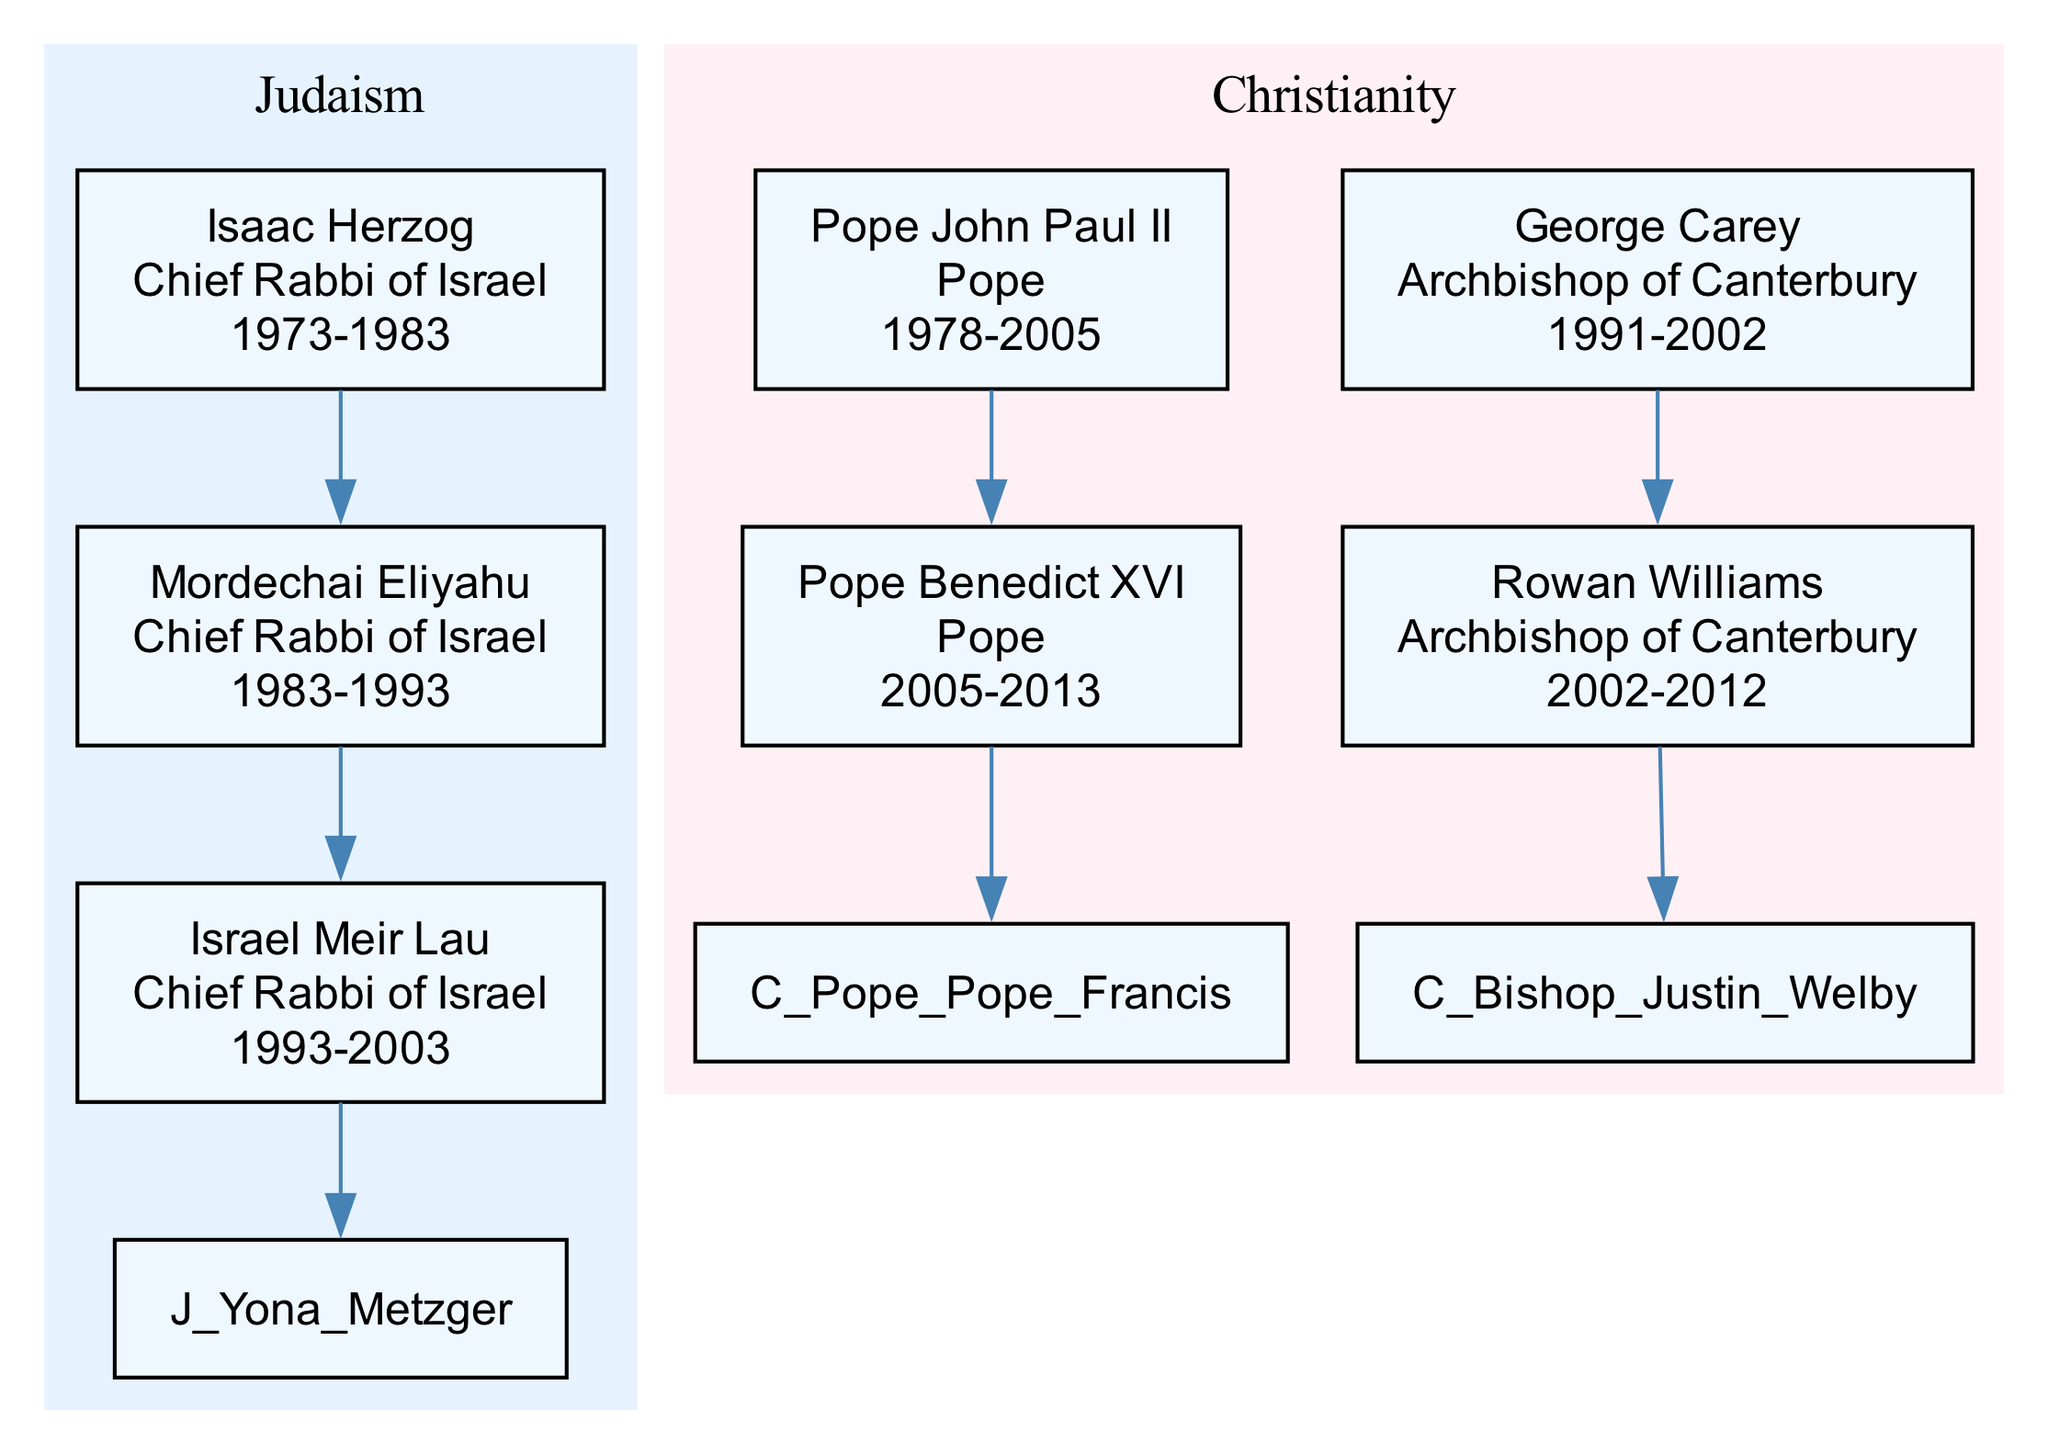What is the title of Isaac Herzog? The diagram shows that Isaac Herzog held the title of "Chief Rabbi of Israel." This information is directly presented in the node associated with his name in the Judaism section.
Answer: Chief Rabbi of Israel Who succeeded Pope Benedict XVI? The diagram indicates that Pope Benedict XVI's successor is Pope Francis. This is shown by the edge that connects their respective nodes in the Christianity section.
Answer: Pope Francis How many chief rabbis are mentioned in the diagram? The diagram lists three chief rabbis of Israel: Isaac Herzog, Mordechai Eliyahu, and Israel Meir Lau. Counting the entries under the Judaism lineage, we arrive at the total.
Answer: 3 What years did Rowan Williams serve as Archbishop of Canterbury? The diagram specifies that Rowan Williams was active as Archbishop of Canterbury from 2002 to 2012. This information is clearly shown in his node within the Christianity section.
Answer: 2002-2012 Which religious leader had the longest tenure in the diagram? Analyzing the years active, Pope John Paul II served from 1978 to 2005, totaling 27 years, which is longer than the tenures of the other leaders listed. This comparison confirms his extended leadership.
Answer: Pope John Paul II What is the succession relationship between Yona Metzger and Israel Meir Lau? The diagram illustrates that Yona Metzger succeeded Israel Meir Lau as Chief Rabbi of Israel. This is indicated by the directional edge connecting their nodes in the Judaism section.
Answer: Yona Metzger succeeded How many bishops are listed in the diagram? The diagram presents two archbishops listed under the Christianity bishops section: George Carey and Rowan Williams. Therefore, counting these distinct entries gives us the total number of bishops.
Answer: 2 Who was the successor of Isaac Herzog? According to the diagram, Isaac Herzog was succeeded by Mordechai Eliyahu. This is shown through the arrow connecting their respective nodes in the Judaism lineage.
Answer: Mordechai Eliyahu What title did Justin Welby hold? The diagram designates Justin Welby with the title of "Archbishop of Canterbury," which appears in his specific node within the Christianity bishops section.
Answer: Archbishop of Canterbury 